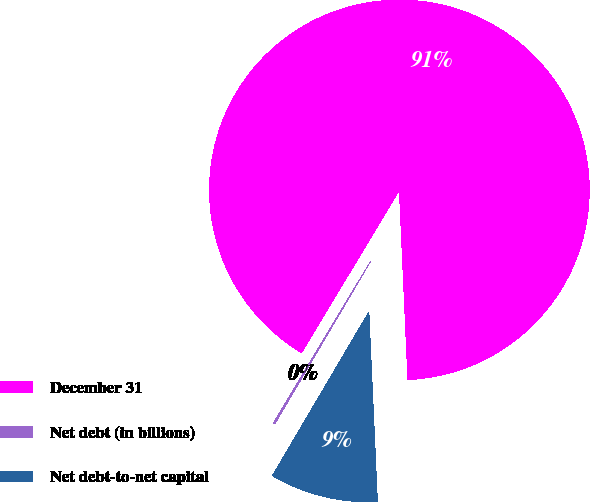<chart> <loc_0><loc_0><loc_500><loc_500><pie_chart><fcel>December 31<fcel>Net debt (in billions)<fcel>Net debt-to-net capital<nl><fcel>90.67%<fcel>0.14%<fcel>9.19%<nl></chart> 